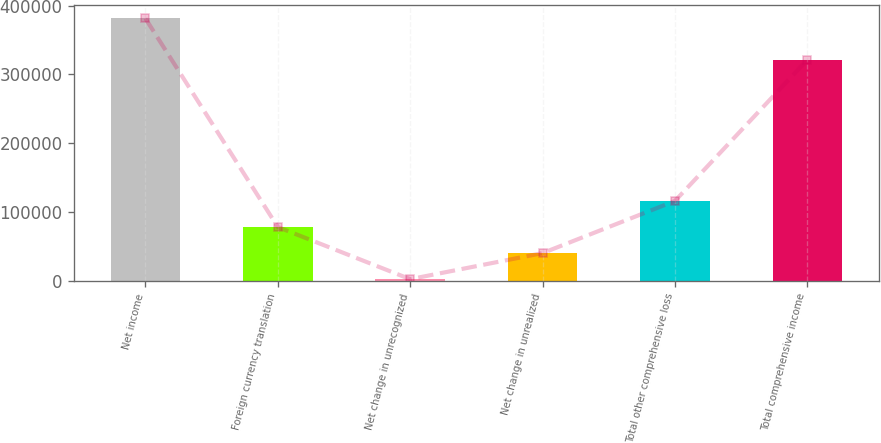<chart> <loc_0><loc_0><loc_500><loc_500><bar_chart><fcel>Net income<fcel>Foreign currency translation<fcel>Net change in unrecognized<fcel>Net change in unrealized<fcel>Total other comprehensive loss<fcel>Total comprehensive income<nl><fcel>381519<fcel>78059.8<fcel>2195<fcel>40127.4<fcel>115992<fcel>321283<nl></chart> 